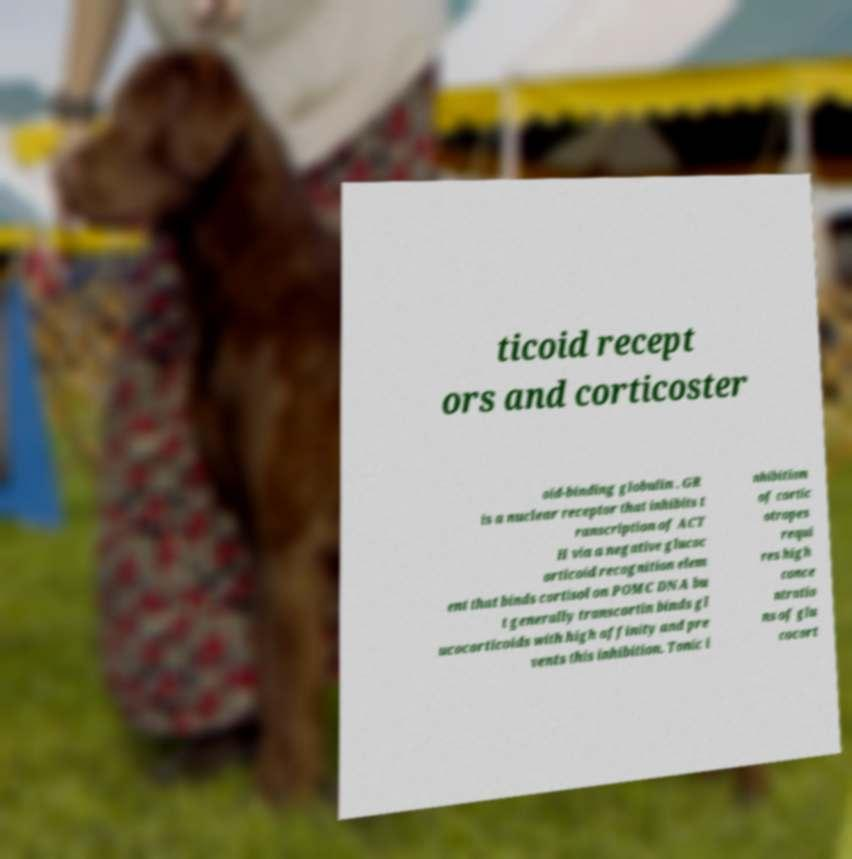What messages or text are displayed in this image? I need them in a readable, typed format. ticoid recept ors and corticoster oid-binding globulin . GR is a nuclear receptor that inhibits t ranscription of ACT H via a negative glucoc orticoid recognition elem ent that binds cortisol on POMC DNA bu t generally transcortin binds gl ucocorticoids with high affinity and pre vents this inhibition. Tonic i nhibition of cortic otropes requi res high conce ntratio ns of glu cocort 